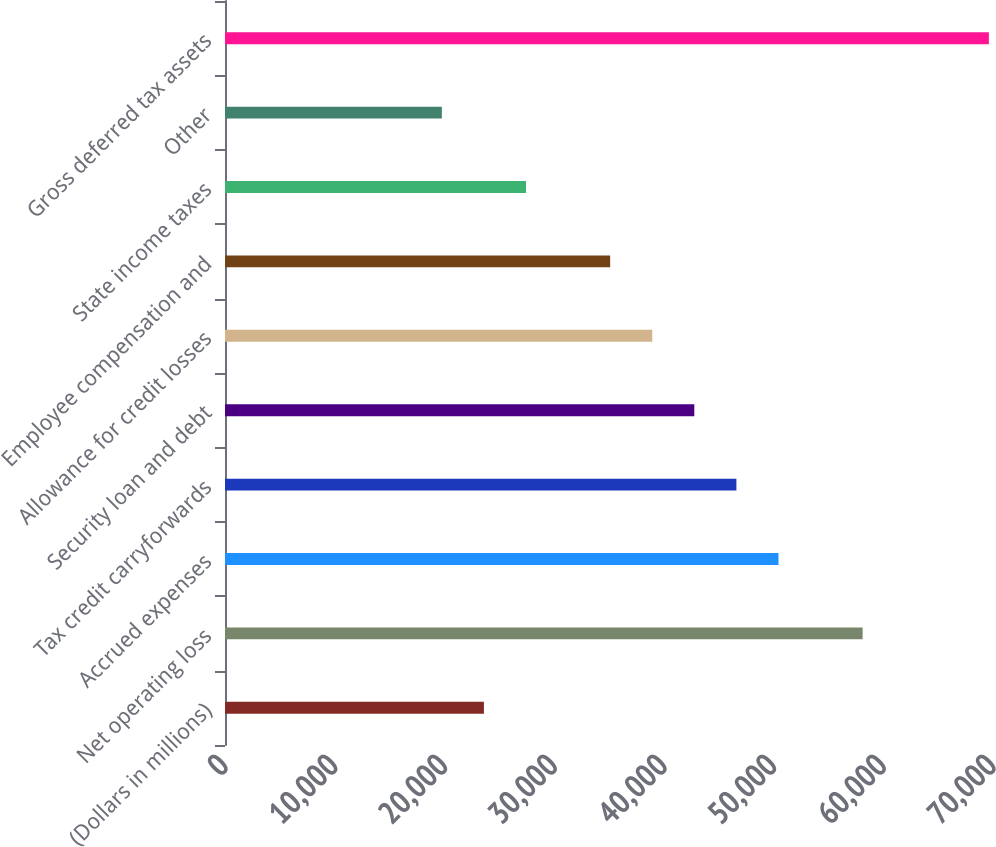Convert chart to OTSL. <chart><loc_0><loc_0><loc_500><loc_500><bar_chart><fcel>(Dollars in millions)<fcel>Net operating loss<fcel>Accrued expenses<fcel>Tax credit carryforwards<fcel>Security loan and debt<fcel>Allowance for credit losses<fcel>Employee compensation and<fcel>State income taxes<fcel>Other<fcel>Gross deferred tax assets<nl><fcel>23599.4<fcel>58118<fcel>50447.2<fcel>46611.8<fcel>42776.4<fcel>38941<fcel>35105.6<fcel>27434.8<fcel>19764<fcel>69624.2<nl></chart> 